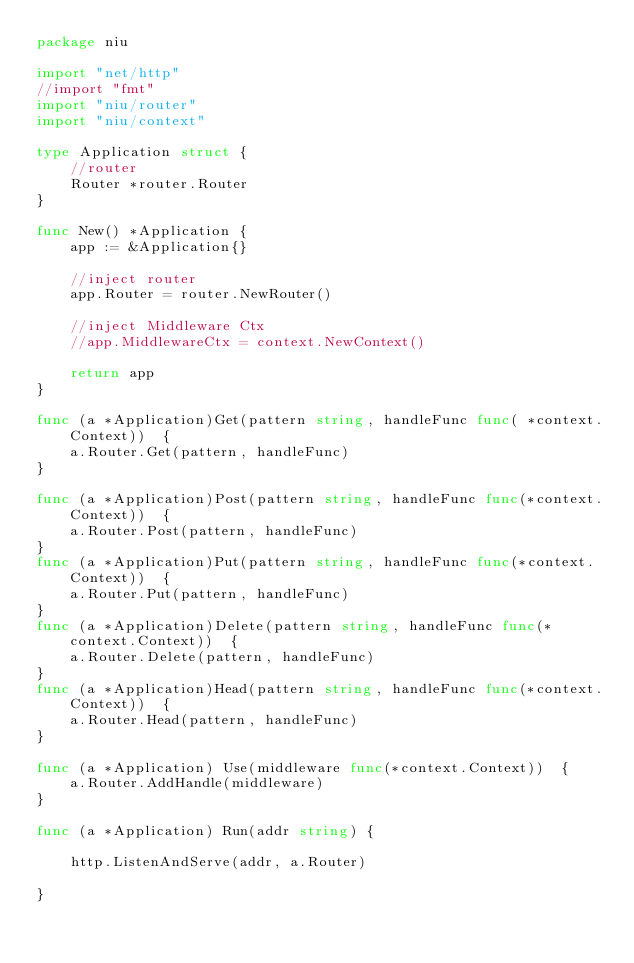<code> <loc_0><loc_0><loc_500><loc_500><_Go_>package niu

import "net/http"
//import "fmt"
import "niu/router"
import "niu/context"

type Application struct {
	//router
	Router *router.Router
}

func New() *Application {
	app := &Application{}

	//inject router
	app.Router = router.NewRouter()

	//inject Middleware Ctx
	//app.MiddlewareCtx = context.NewContext()

	return app
}

func (a *Application)Get(pattern string, handleFunc func( *context.Context))  {
	a.Router.Get(pattern, handleFunc)
}

func (a *Application)Post(pattern string, handleFunc func(*context.Context))  {
	a.Router.Post(pattern, handleFunc)
}
func (a *Application)Put(pattern string, handleFunc func(*context.Context))  {
	a.Router.Put(pattern, handleFunc)
}
func (a *Application)Delete(pattern string, handleFunc func(*context.Context))  {
	a.Router.Delete(pattern, handleFunc)
}
func (a *Application)Head(pattern string, handleFunc func(*context.Context))  {
	a.Router.Head(pattern, handleFunc)
}

func (a *Application) Use(middleware func(*context.Context))  {
	a.Router.AddHandle(middleware)
}

func (a *Application) Run(addr string) {

	http.ListenAndServe(addr, a.Router)

}


</code> 